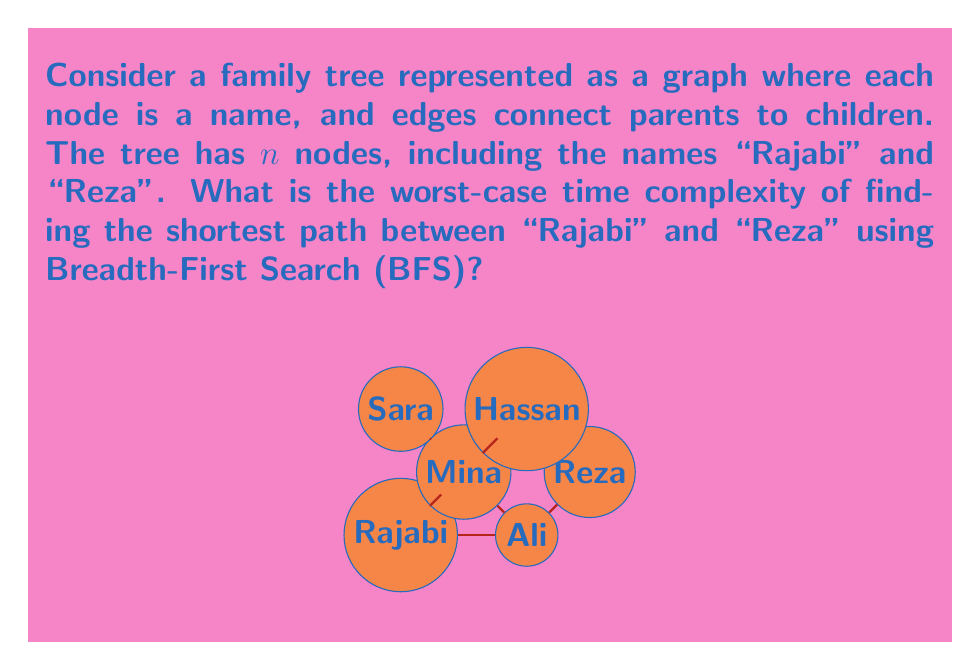Give your solution to this math problem. To find the shortest path between two nodes in a graph using Breadth-First Search (BFS), we need to analyze the algorithm's complexity:

1) BFS visits all nodes in the graph level by level, starting from the source node ("Rajabi" in this case).

2) In the worst case, BFS may need to visit all nodes and edges in the graph before reaching the target node ("Reza").

3) The time complexity of BFS is $O(V + E)$, where $V$ is the number of vertices (nodes) and $E$ is the number of edges in the graph.

4) In a family tree:
   - The number of nodes is $n$ (given in the question).
   - The number of edges is at most $n-1$ (since it's a tree structure).

5) Therefore, the worst-case time complexity can be expressed as:
   $$O(V + E) = O(n + (n-1)) = O(2n - 1) = O(n)$$

6) The space complexity is also $O(n)$ due to the queue used in BFS and the visited nodes tracking.

Note: This analysis assumes that the graph is stored in an adjacency list representation. If it's stored as an adjacency matrix, the time complexity would be $O(n^2)$.
Answer: $O(n)$ 